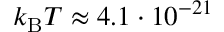<formula> <loc_0><loc_0><loc_500><loc_500>k _ { B } T \approx 4 . 1 \cdot 1 0 ^ { - 2 1 }</formula> 